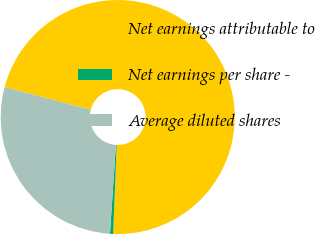Convert chart. <chart><loc_0><loc_0><loc_500><loc_500><pie_chart><fcel>Net earnings attributable to<fcel>Net earnings per share -<fcel>Average diluted shares<nl><fcel>71.5%<fcel>0.43%<fcel>28.08%<nl></chart> 